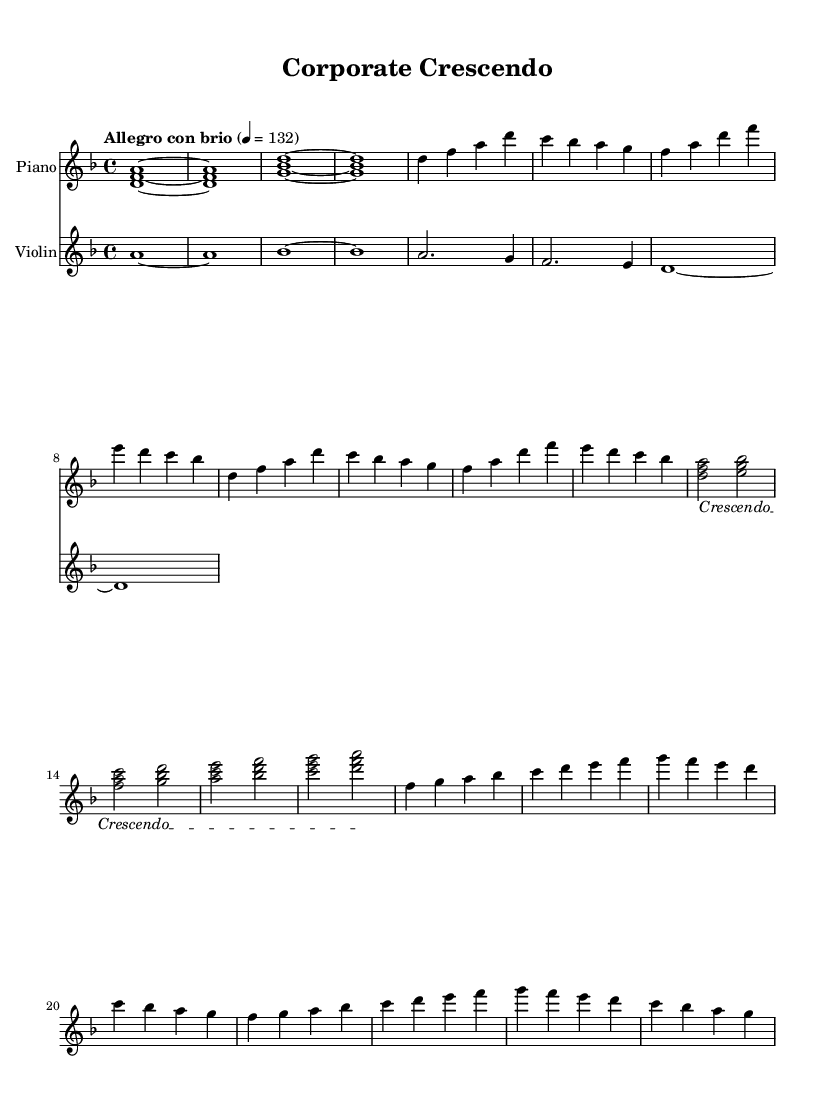What is the key signature of this music? The key signature is D minor, as indicated at the beginning of the score with one flat (B flat).
Answer: D minor What is the time signature of this piece? The time signature is 4/4, which shows that there are four beats in each measure.
Answer: 4/4 What is the indicated tempo for this composition? The tempo marking states "Allegro con brio" at quarter note equals 132 beats per minute, suggesting a lively and brisk pace.
Answer: Allegro con brio 4 = 132 How many measures are in the main theme A section? The main theme A consists of four measures, as visible in the repeated phrases from the beginning section.
Answer: 4 What musical technique is used to build tension in this score? The score uses a crescendo technique, as indicated by the text spanner marking that shows a gradual increase in volume.
Answer: Crescendo Which instrument plays the main melodic theme? The piano part primarily features the main melodic theme throughout the score, as indicated by the instrumentation title at the top.
Answer: Piano How many times does the main theme B repeat through the score? The main theme B is repeated twice in succession, as seen in the structured notation presented after the tension build section.
Answer: 2 